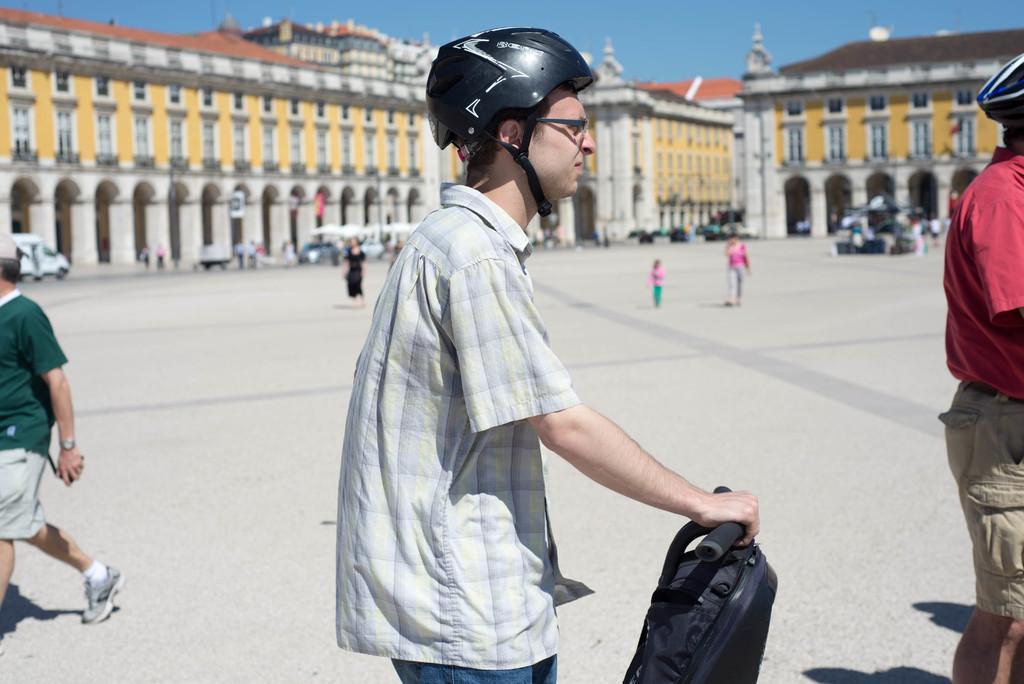In one or two sentences, can you explain what this image depicts? In the center of the image there is a person wearing a helmet and holding a bag. In the background of the image there is a building. There are cars. There are people walking. At the bottom of the image there is road. 